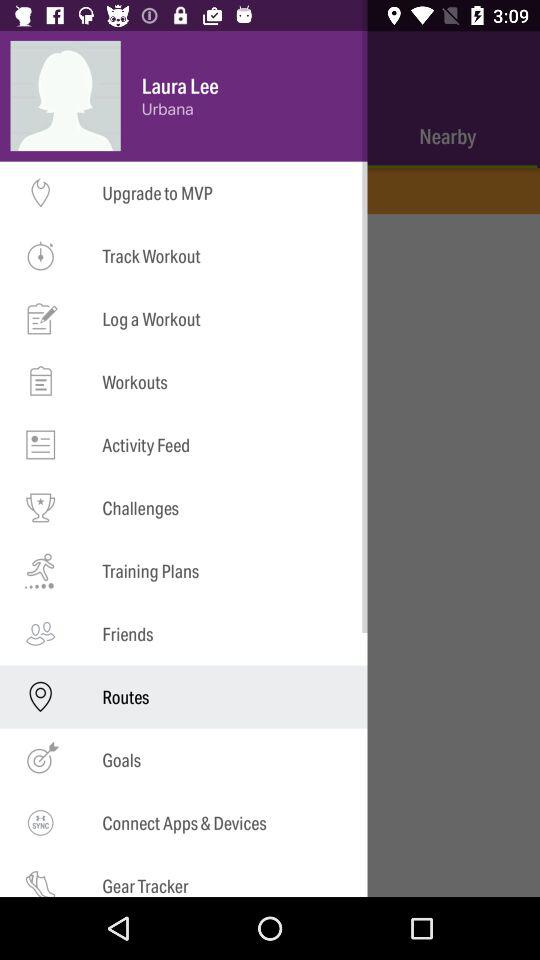What is the user name? The user name is Laura Lee. 